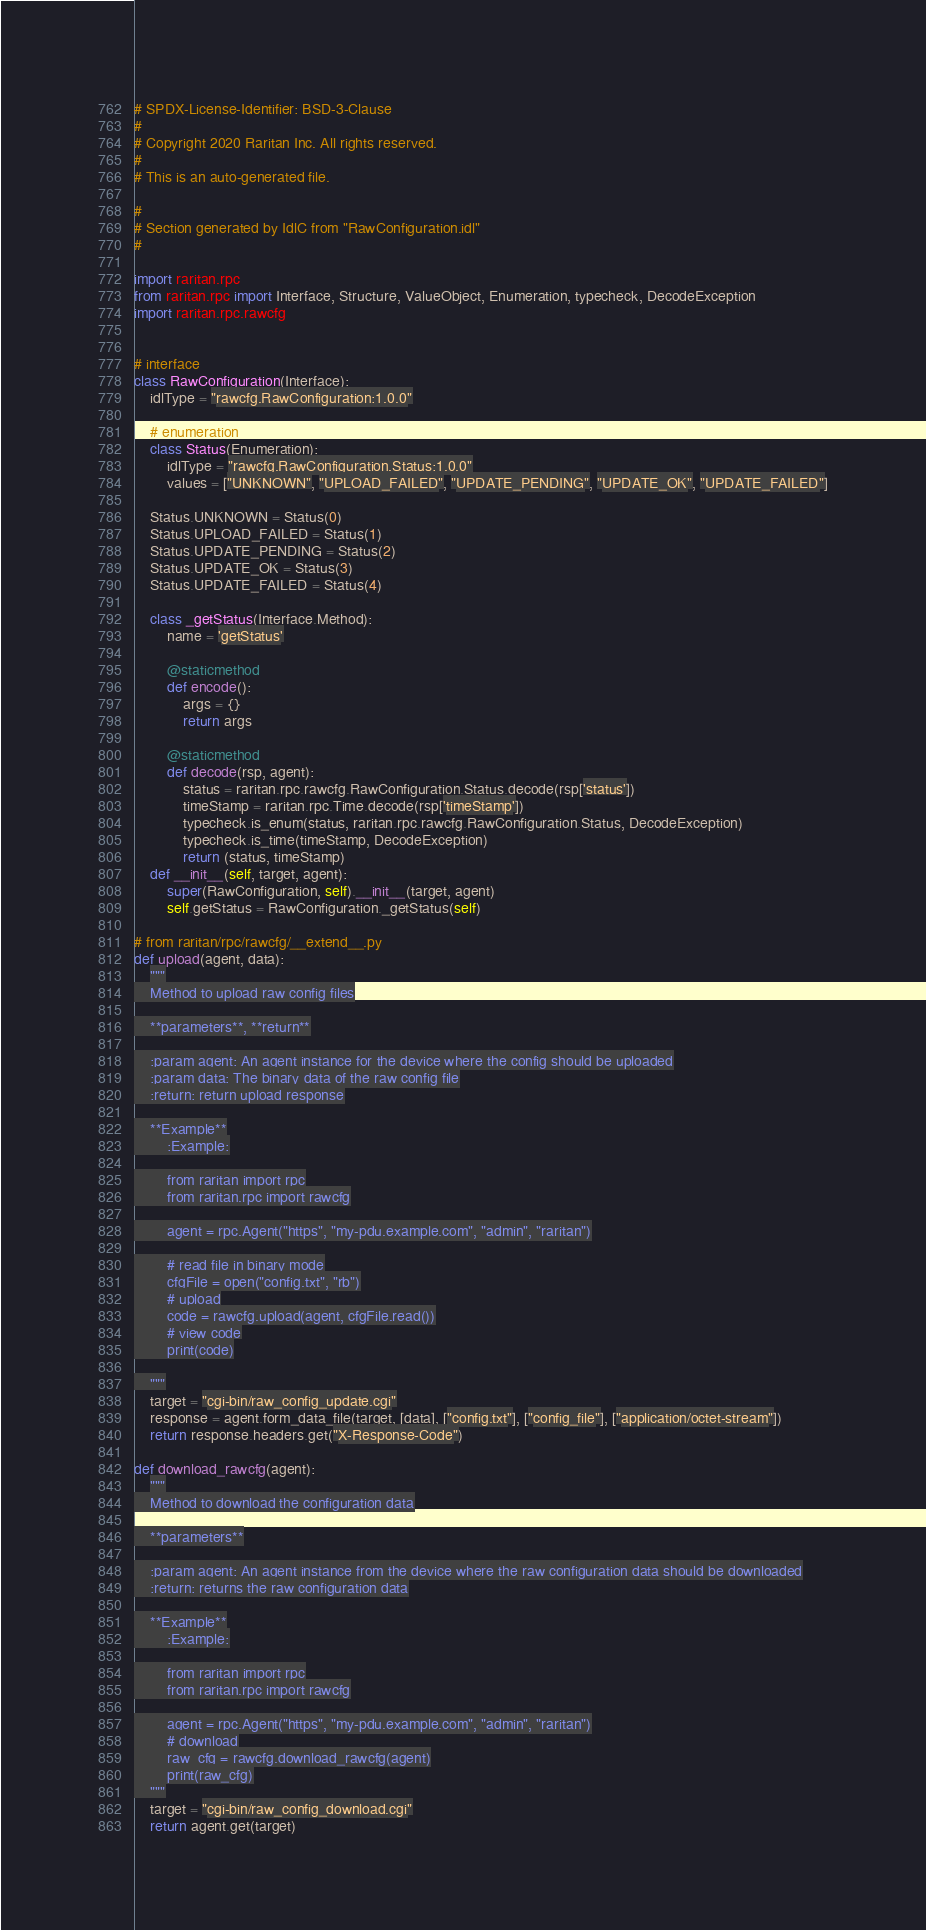<code> <loc_0><loc_0><loc_500><loc_500><_Python_># SPDX-License-Identifier: BSD-3-Clause
#
# Copyright 2020 Raritan Inc. All rights reserved.
#
# This is an auto-generated file.

#
# Section generated by IdlC from "RawConfiguration.idl"
#

import raritan.rpc
from raritan.rpc import Interface, Structure, ValueObject, Enumeration, typecheck, DecodeException
import raritan.rpc.rawcfg


# interface
class RawConfiguration(Interface):
    idlType = "rawcfg.RawConfiguration:1.0.0"

    # enumeration
    class Status(Enumeration):
        idlType = "rawcfg.RawConfiguration.Status:1.0.0"
        values = ["UNKNOWN", "UPLOAD_FAILED", "UPDATE_PENDING", "UPDATE_OK", "UPDATE_FAILED"]

    Status.UNKNOWN = Status(0)
    Status.UPLOAD_FAILED = Status(1)
    Status.UPDATE_PENDING = Status(2)
    Status.UPDATE_OK = Status(3)
    Status.UPDATE_FAILED = Status(4)

    class _getStatus(Interface.Method):
        name = 'getStatus'

        @staticmethod
        def encode():
            args = {}
            return args

        @staticmethod
        def decode(rsp, agent):
            status = raritan.rpc.rawcfg.RawConfiguration.Status.decode(rsp['status'])
            timeStamp = raritan.rpc.Time.decode(rsp['timeStamp'])
            typecheck.is_enum(status, raritan.rpc.rawcfg.RawConfiguration.Status, DecodeException)
            typecheck.is_time(timeStamp, DecodeException)
            return (status, timeStamp)
    def __init__(self, target, agent):
        super(RawConfiguration, self).__init__(target, agent)
        self.getStatus = RawConfiguration._getStatus(self)

# from raritan/rpc/rawcfg/__extend__.py
def upload(agent, data):
    """
    Method to upload raw config files

    **parameters**, **return**

    :param agent: An agent instance for the device where the config should be uploaded
    :param data: The binary data of the raw config file
    :return: return upload response

    **Example**
        :Example:

        from raritan import rpc
        from raritan.rpc import rawcfg

        agent = rpc.Agent("https", "my-pdu.example.com", "admin", "raritan")

        # read file in binary mode
        cfgFile = open("config.txt", "rb")
        # upload
        code = rawcfg.upload(agent, cfgFile.read())
        # view code
        print(code)

    """
    target = "cgi-bin/raw_config_update.cgi"
    response = agent.form_data_file(target, [data], ["config.txt"], ["config_file"], ["application/octet-stream"])
    return response.headers.get("X-Response-Code")

def download_rawcfg(agent):
    """
    Method to download the configuration data

    **parameters**

    :param agent: An agent instance from the device where the raw configuration data should be downloaded
    :return: returns the raw configuration data

    **Example**
        :Example:

        from raritan import rpc
        from raritan.rpc import rawcfg

        agent = rpc.Agent("https", "my-pdu.example.com", "admin", "raritan")
        # download
        raw_cfg = rawcfg.download_rawcfg(agent)
        print(raw_cfg)
    """
    target = "cgi-bin/raw_config_download.cgi"
    return agent.get(target)
</code> 